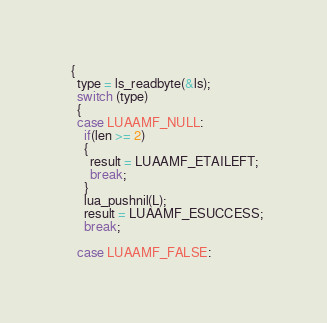<code> <loc_0><loc_0><loc_500><loc_500><_C_>  {
    type = ls_readbyte(&ls);
    switch (type)
    {
    case LUAAMF_NULL:
      if(len >= 2)
      {
        result = LUAAMF_ETAILEFT;
        break;
      }
      lua_pushnil(L);
      result = LUAAMF_ESUCCESS;
      break;

    case LUAAMF_FALSE:</code> 